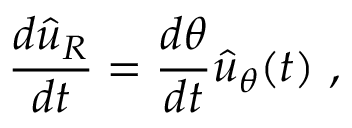Convert formula to latex. <formula><loc_0><loc_0><loc_500><loc_500>{ \frac { d { \hat { u } } _ { R } } { d t } } = { \frac { d \theta } { d t } } { \hat { u } } _ { \theta } ( t ) \ ,</formula> 